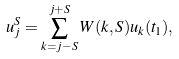<formula> <loc_0><loc_0><loc_500><loc_500>u _ { j } ^ { S } = \sum _ { k = j - S } ^ { j + S } W ( k , S ) u _ { k } ( t _ { 1 } ) ,</formula> 